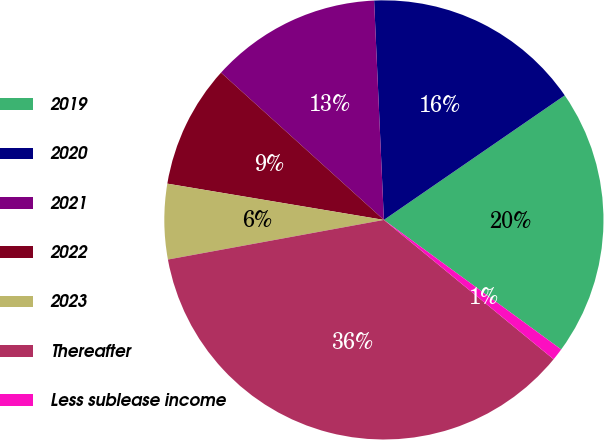<chart> <loc_0><loc_0><loc_500><loc_500><pie_chart><fcel>2019<fcel>2020<fcel>2021<fcel>2022<fcel>2023<fcel>Thereafter<fcel>Less sublease income<nl><fcel>19.64%<fcel>16.11%<fcel>12.59%<fcel>9.06%<fcel>5.53%<fcel>36.17%<fcel>0.9%<nl></chart> 